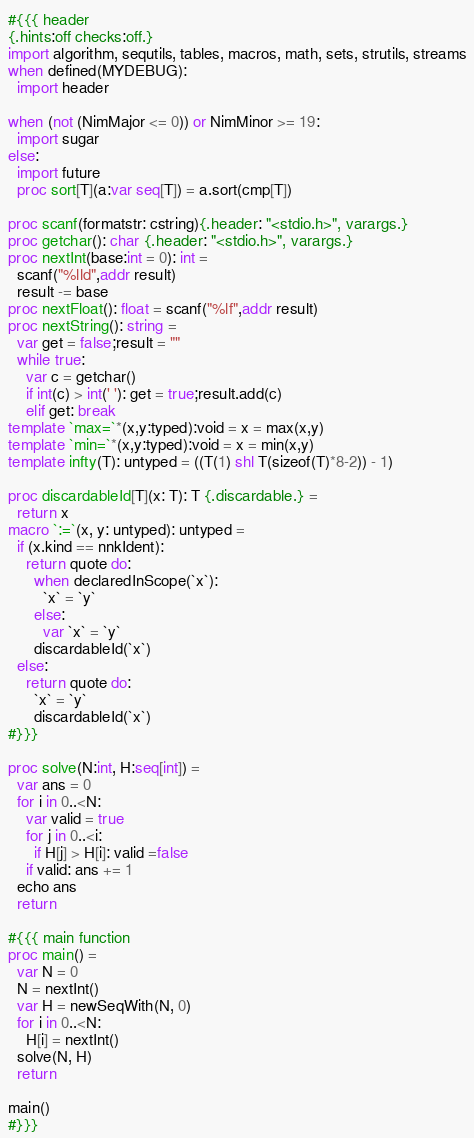Convert code to text. <code><loc_0><loc_0><loc_500><loc_500><_Nim_>#{{{ header
{.hints:off checks:off.}
import algorithm, sequtils, tables, macros, math, sets, strutils, streams
when defined(MYDEBUG):
  import header

when (not (NimMajor <= 0)) or NimMinor >= 19:
  import sugar
else:
  import future
  proc sort[T](a:var seq[T]) = a.sort(cmp[T])

proc scanf(formatstr: cstring){.header: "<stdio.h>", varargs.}
proc getchar(): char {.header: "<stdio.h>", varargs.}
proc nextInt(base:int = 0): int =
  scanf("%lld",addr result)
  result -= base
proc nextFloat(): float = scanf("%lf",addr result)
proc nextString(): string =
  var get = false;result = ""
  while true:
    var c = getchar()
    if int(c) > int(' '): get = true;result.add(c)
    elif get: break
template `max=`*(x,y:typed):void = x = max(x,y)
template `min=`*(x,y:typed):void = x = min(x,y)
template infty(T): untyped = ((T(1) shl T(sizeof(T)*8-2)) - 1)

proc discardableId[T](x: T): T {.discardable.} =
  return x
macro `:=`(x, y: untyped): untyped =
  if (x.kind == nnkIdent):
    return quote do:
      when declaredInScope(`x`):
        `x` = `y`
      else:
        var `x` = `y`
      discardableId(`x`)
  else:
    return quote do:
      `x` = `y`
      discardableId(`x`)
#}}}

proc solve(N:int, H:seq[int]) =
  var ans = 0
  for i in 0..<N:
    var valid = true
    for j in 0..<i:
      if H[j] > H[i]: valid =false
    if valid: ans += 1
  echo ans
  return

#{{{ main function
proc main() =
  var N = 0
  N = nextInt()
  var H = newSeqWith(N, 0)
  for i in 0..<N:
    H[i] = nextInt()
  solve(N, H)
  return

main()
#}}}
</code> 